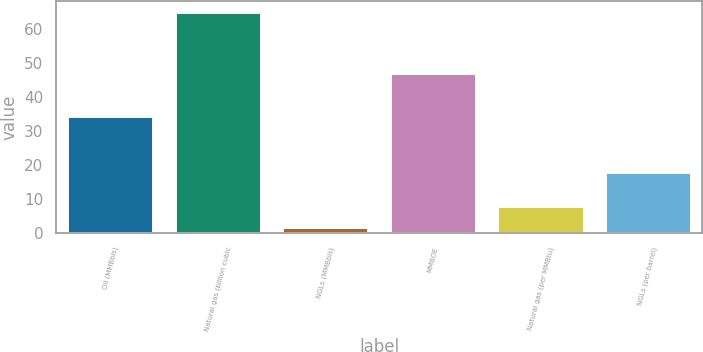Convert chart. <chart><loc_0><loc_0><loc_500><loc_500><bar_chart><fcel>Oil (MMBbls)<fcel>Natural gas (billion cubic<fcel>NGLs (MMBbls)<fcel>MMBOE<fcel>Natural gas (per MMBtu)<fcel>NGLs (per barrel)<nl><fcel>34.4<fcel>65.1<fcel>1.8<fcel>47.1<fcel>8.13<fcel>18.11<nl></chart> 